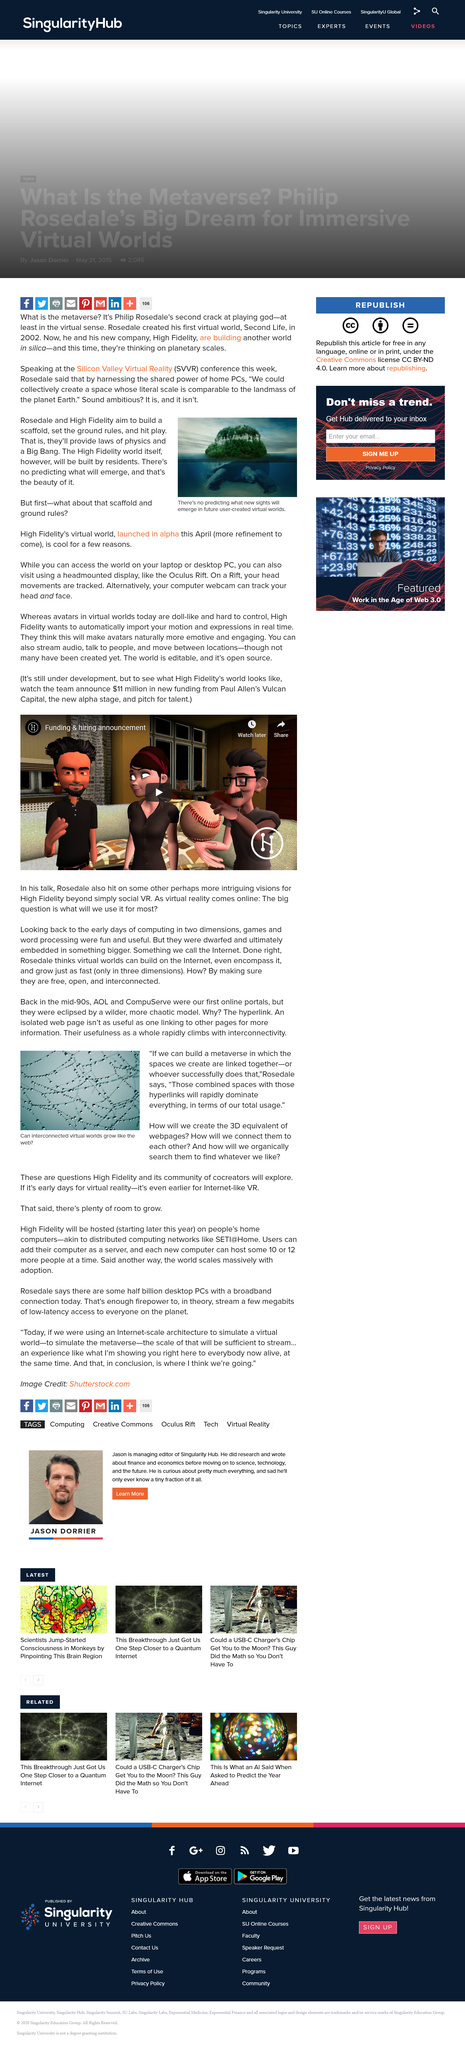Indicate a few pertinent items in this graphic. As stated by Rosedale, 'If we can build a metaverse in which the spaces we create are linked together, or whoever successfully does that, we will have achieved something truly remarkable.' In 2002, Rosedale created his first virtual world. Rosedale's first virtual world was named Second Life. The first online portals were AOL and CompuServe. High Fidelity and its community of cocreators will explore and develop innovative solutions for creating 3D representations of websites and connecting them to each other in a seamless and intuitive way, allowing for organic search and discovery of content. 